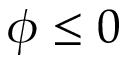Convert formula to latex. <formula><loc_0><loc_0><loc_500><loc_500>\phi \leq 0</formula> 